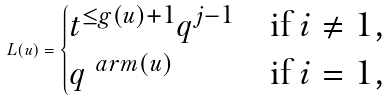<formula> <loc_0><loc_0><loc_500><loc_500>L ( u ) = \begin{cases} t ^ { \leq g ( u ) + 1 } q ^ { j - 1 } & \text {if $i\not =1$} , \\ q ^ { \ a r m ( u ) } & \text {if $i=1$} , \end{cases}</formula> 